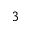Convert formula to latex. <formula><loc_0><loc_0><loc_500><loc_500>^ { 3 }</formula> 